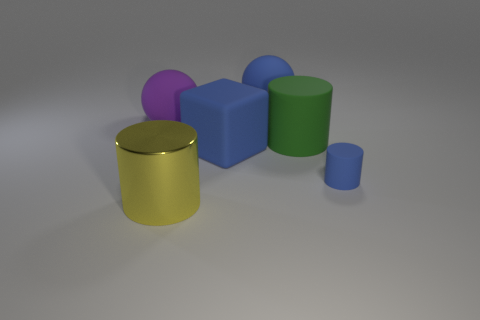Are there any other things that have the same material as the large yellow thing?
Offer a very short reply. No. There is a large cylinder that is on the left side of the blue rubber thing behind the big green cylinder; what is it made of?
Offer a terse response. Metal. What number of objects are either large cylinders to the right of the big blue rubber ball or blue balls?
Make the answer very short. 2. Are there an equal number of tiny blue cylinders that are on the left side of the big yellow metal object and tiny blue cylinders that are on the right side of the big green rubber thing?
Your response must be concise. No. The blue object behind the sphere that is left of the cylinder that is in front of the tiny blue cylinder is made of what material?
Your answer should be compact. Rubber. What is the size of the object that is both to the left of the block and behind the green matte cylinder?
Your answer should be very brief. Large. Is the shape of the tiny blue matte object the same as the big shiny thing?
Offer a terse response. Yes. There is a big green object that is made of the same material as the large purple object; what is its shape?
Offer a terse response. Cylinder. How many big things are either green things or blue matte spheres?
Your response must be concise. 2. Are there any things in front of the big blue rubber object that is behind the blue cube?
Your answer should be compact. Yes. 